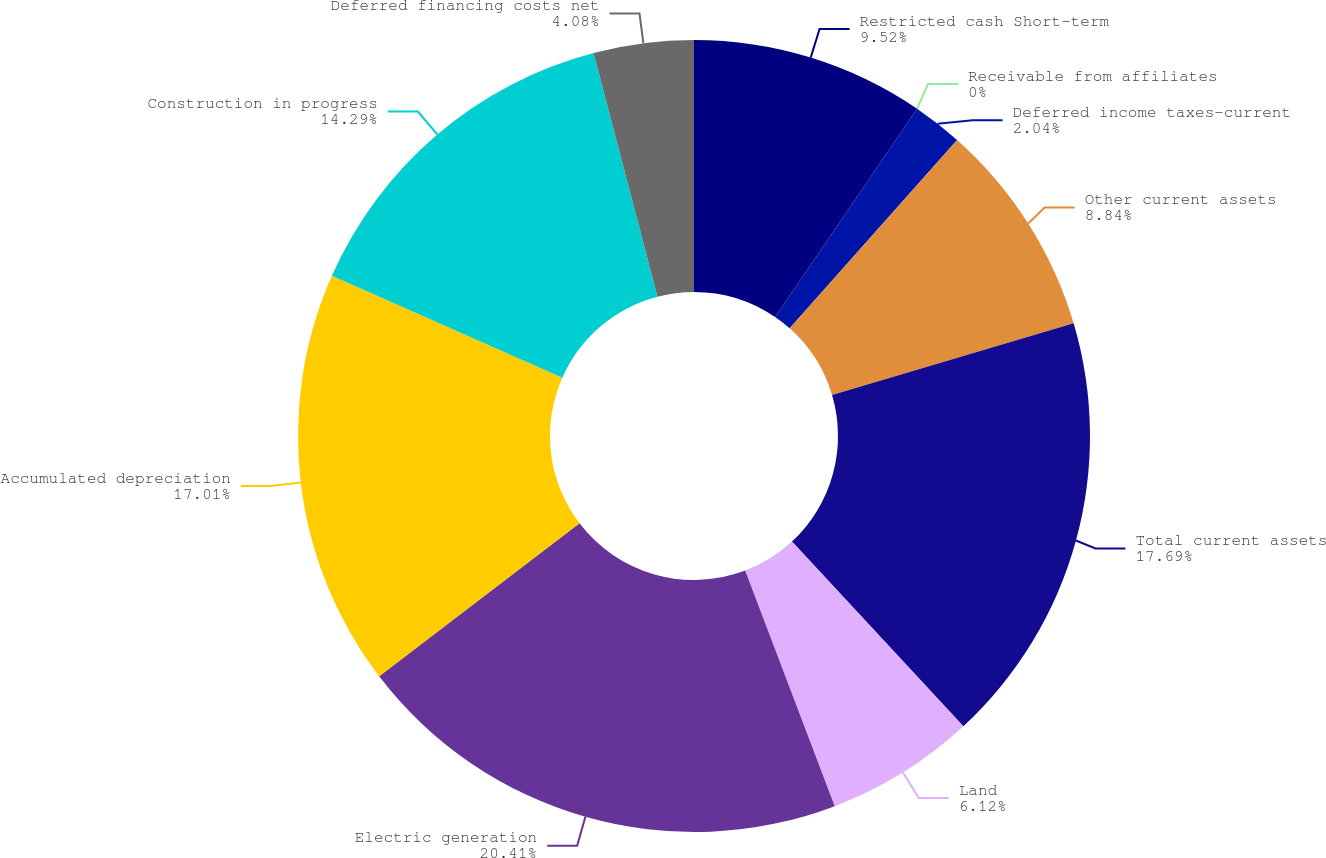<chart> <loc_0><loc_0><loc_500><loc_500><pie_chart><fcel>Restricted cash Short-term<fcel>Receivable from affiliates<fcel>Deferred income taxes-current<fcel>Other current assets<fcel>Total current assets<fcel>Land<fcel>Electric generation<fcel>Accumulated depreciation<fcel>Construction in progress<fcel>Deferred financing costs net<nl><fcel>9.52%<fcel>0.0%<fcel>2.04%<fcel>8.84%<fcel>17.68%<fcel>6.12%<fcel>20.4%<fcel>17.0%<fcel>14.28%<fcel>4.08%<nl></chart> 